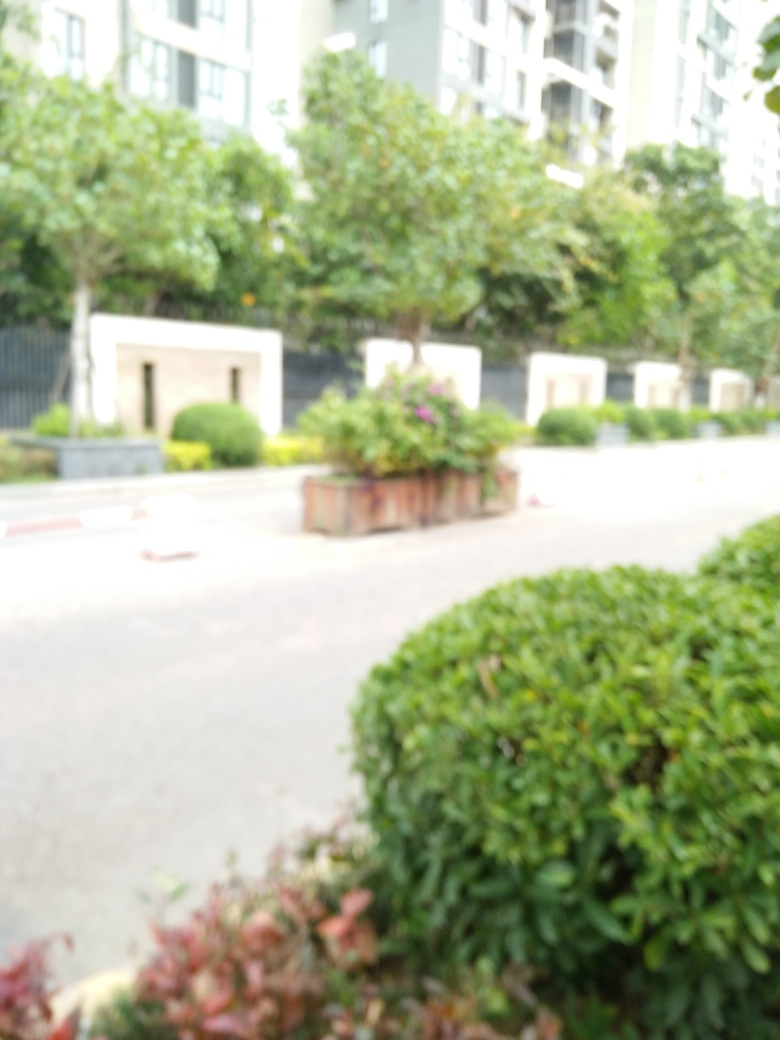What elements can you still make out in this blurred image? Despite the blur, we can identify some elements in the image. There are several large, green bushy plants and a few structures that might be benches or planters. The area suggests a landscaped section, likely part of an outdoor urban space adjacent to tall buildings, possibly a park or garden within a residential or commercial complex. What kind of mood or atmosphere does the blurred image evoke? The blurred quality of the image imparts a dreamy, surreal atmosphere. It can evoke a sense of mystery or soften the real-world appearance of the scene, potentially invoking curiosity or a serene, tranquil vibe, despite not being able to see the details clearly. 